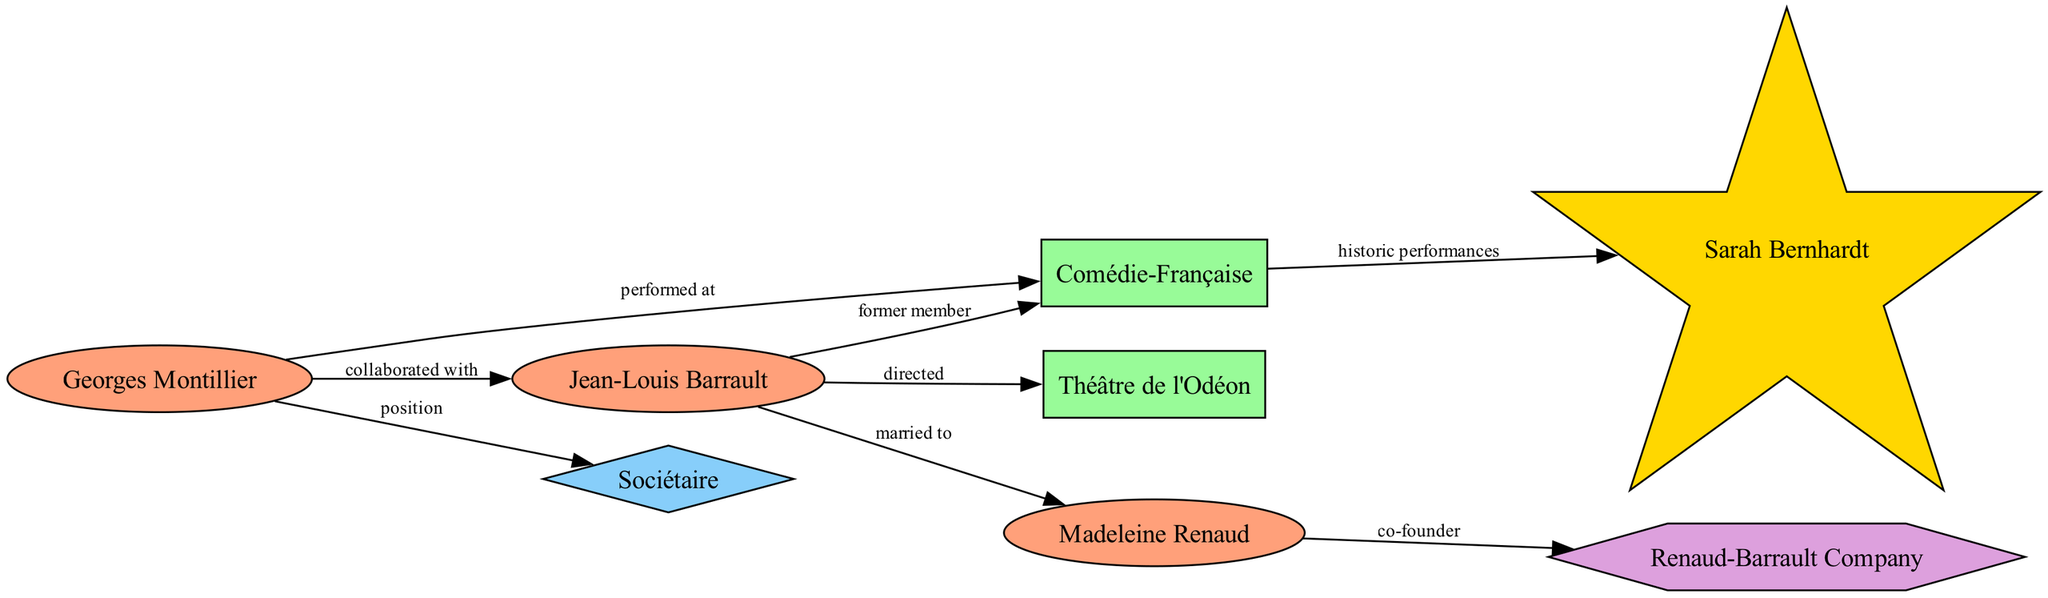What is the total number of nodes in the diagram? To find the total number of nodes, we count them based on the provided data. There are eight nodes listed: Georges Montillier, Comédie-Française, Jean-Louis Barrault, Sociétaire, Théâtre de l'Odéon, Madeleine Renaud, Renaud-Barrault Company, and Sarah Bernhardt.
Answer: 8 Who did Georges Montillier collaborate with? Referring to the edge connections related to Georges Montillier, it is indicated that he collaborated with Jean-Louis Barrault.
Answer: Jean-Louis Barrault What type of performance is associated with the Comédie-Française and Sarah Bernhardt? The edge connecting the Comédie-Française to Sarah Bernhardt shows that they are linked through historic performances. This represents the specific type of performance associated with both.
Answer: historic performances How many actors are present in the diagram? Examining the nodes, we can identify that there are four distinct actors: Georges Montillier, Jean-Louis Barrault, Madeleine Renaud, and Sarah Bernhardt. Therefore, adding them gives the total count.
Answer: 4 Which theatre did Jean-Louis Barrault direct? Based on the edge connecting Jean-Louis Barrault to Théâtre de l'Odéon, it is shown that he directed that theatre, which answers the question directly about his role.
Answer: Théâtre de l'Odéon What relationship is indicated between Madeleine Renaud and the Renaud-Barrault Company? The diagram shows an edge from Madeleine Renaud to the Renaud-Barrault Company labeled as "co-founder," which describes her role in relation to this theatre company.
Answer: co-founder Which historical actor is connected to the Comédie-Française? The edge depicting the connection between the Comédie-Française and Sarah Bernhardt clearly indicates that the historical actor linked to this theatre is Sarah Bernhardt.
Answer: Sarah Bernhardt Who performed at the Comédie-Française? The connection from Georges Montillier to the Comédie-Française indicates he performed there, thus directly answering the question about who performed at this venue.
Answer: Georges Montillier 